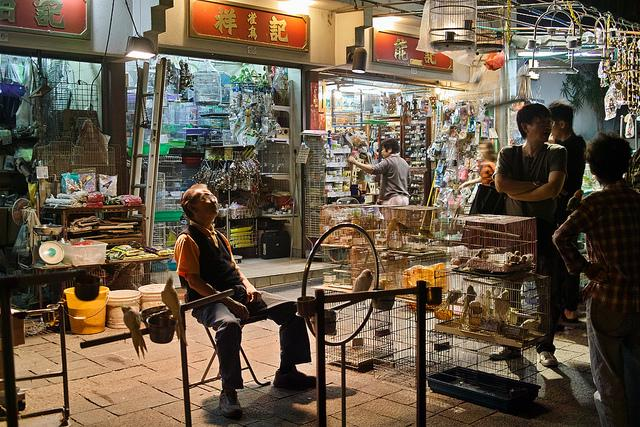The birds seen out of their cage here are sold for what purpose? pets 